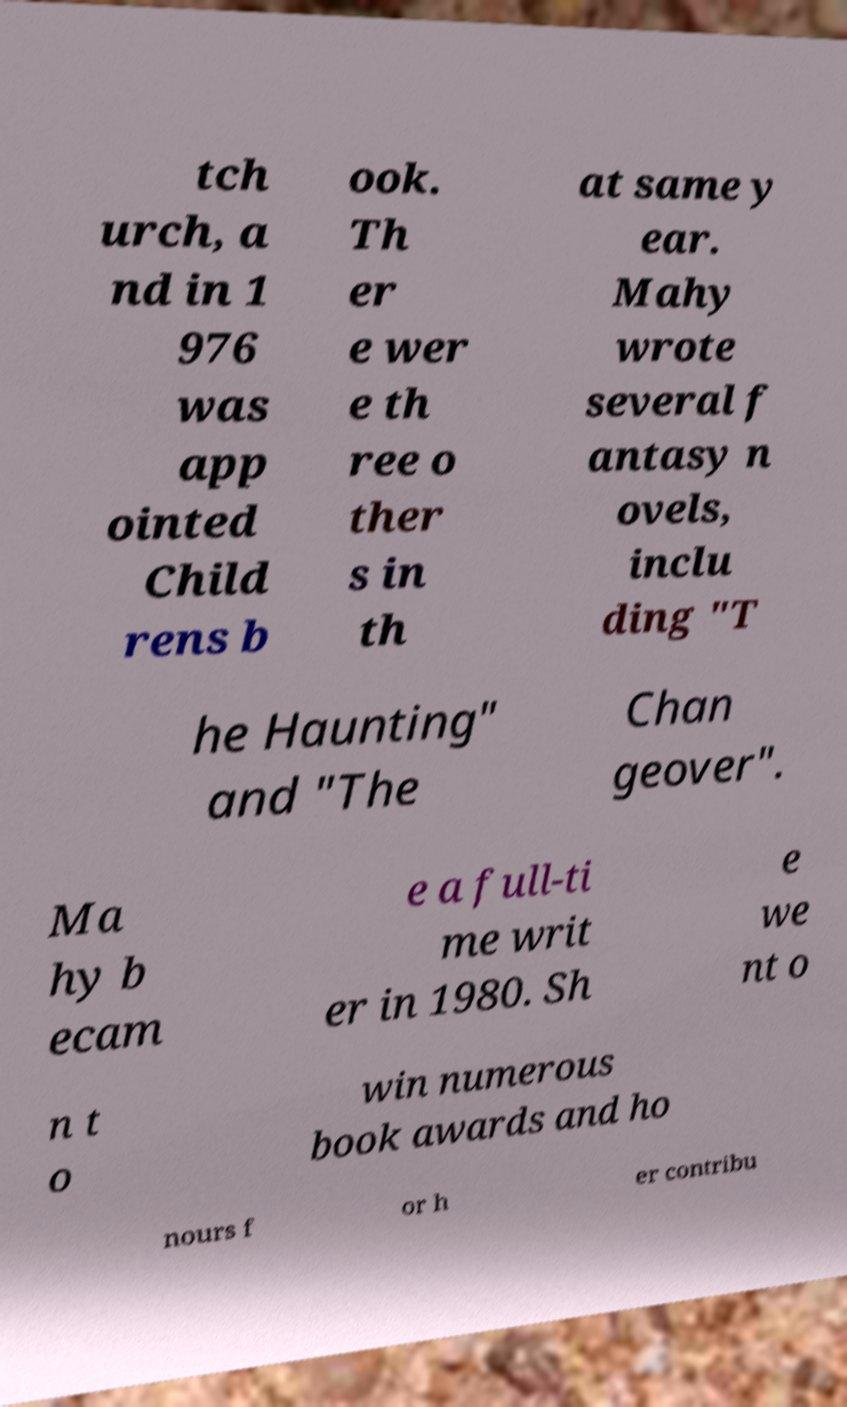Can you accurately transcribe the text from the provided image for me? tch urch, a nd in 1 976 was app ointed Child rens b ook. Th er e wer e th ree o ther s in th at same y ear. Mahy wrote several f antasy n ovels, inclu ding "T he Haunting" and "The Chan geover". Ma hy b ecam e a full-ti me writ er in 1980. Sh e we nt o n t o win numerous book awards and ho nours f or h er contribu 